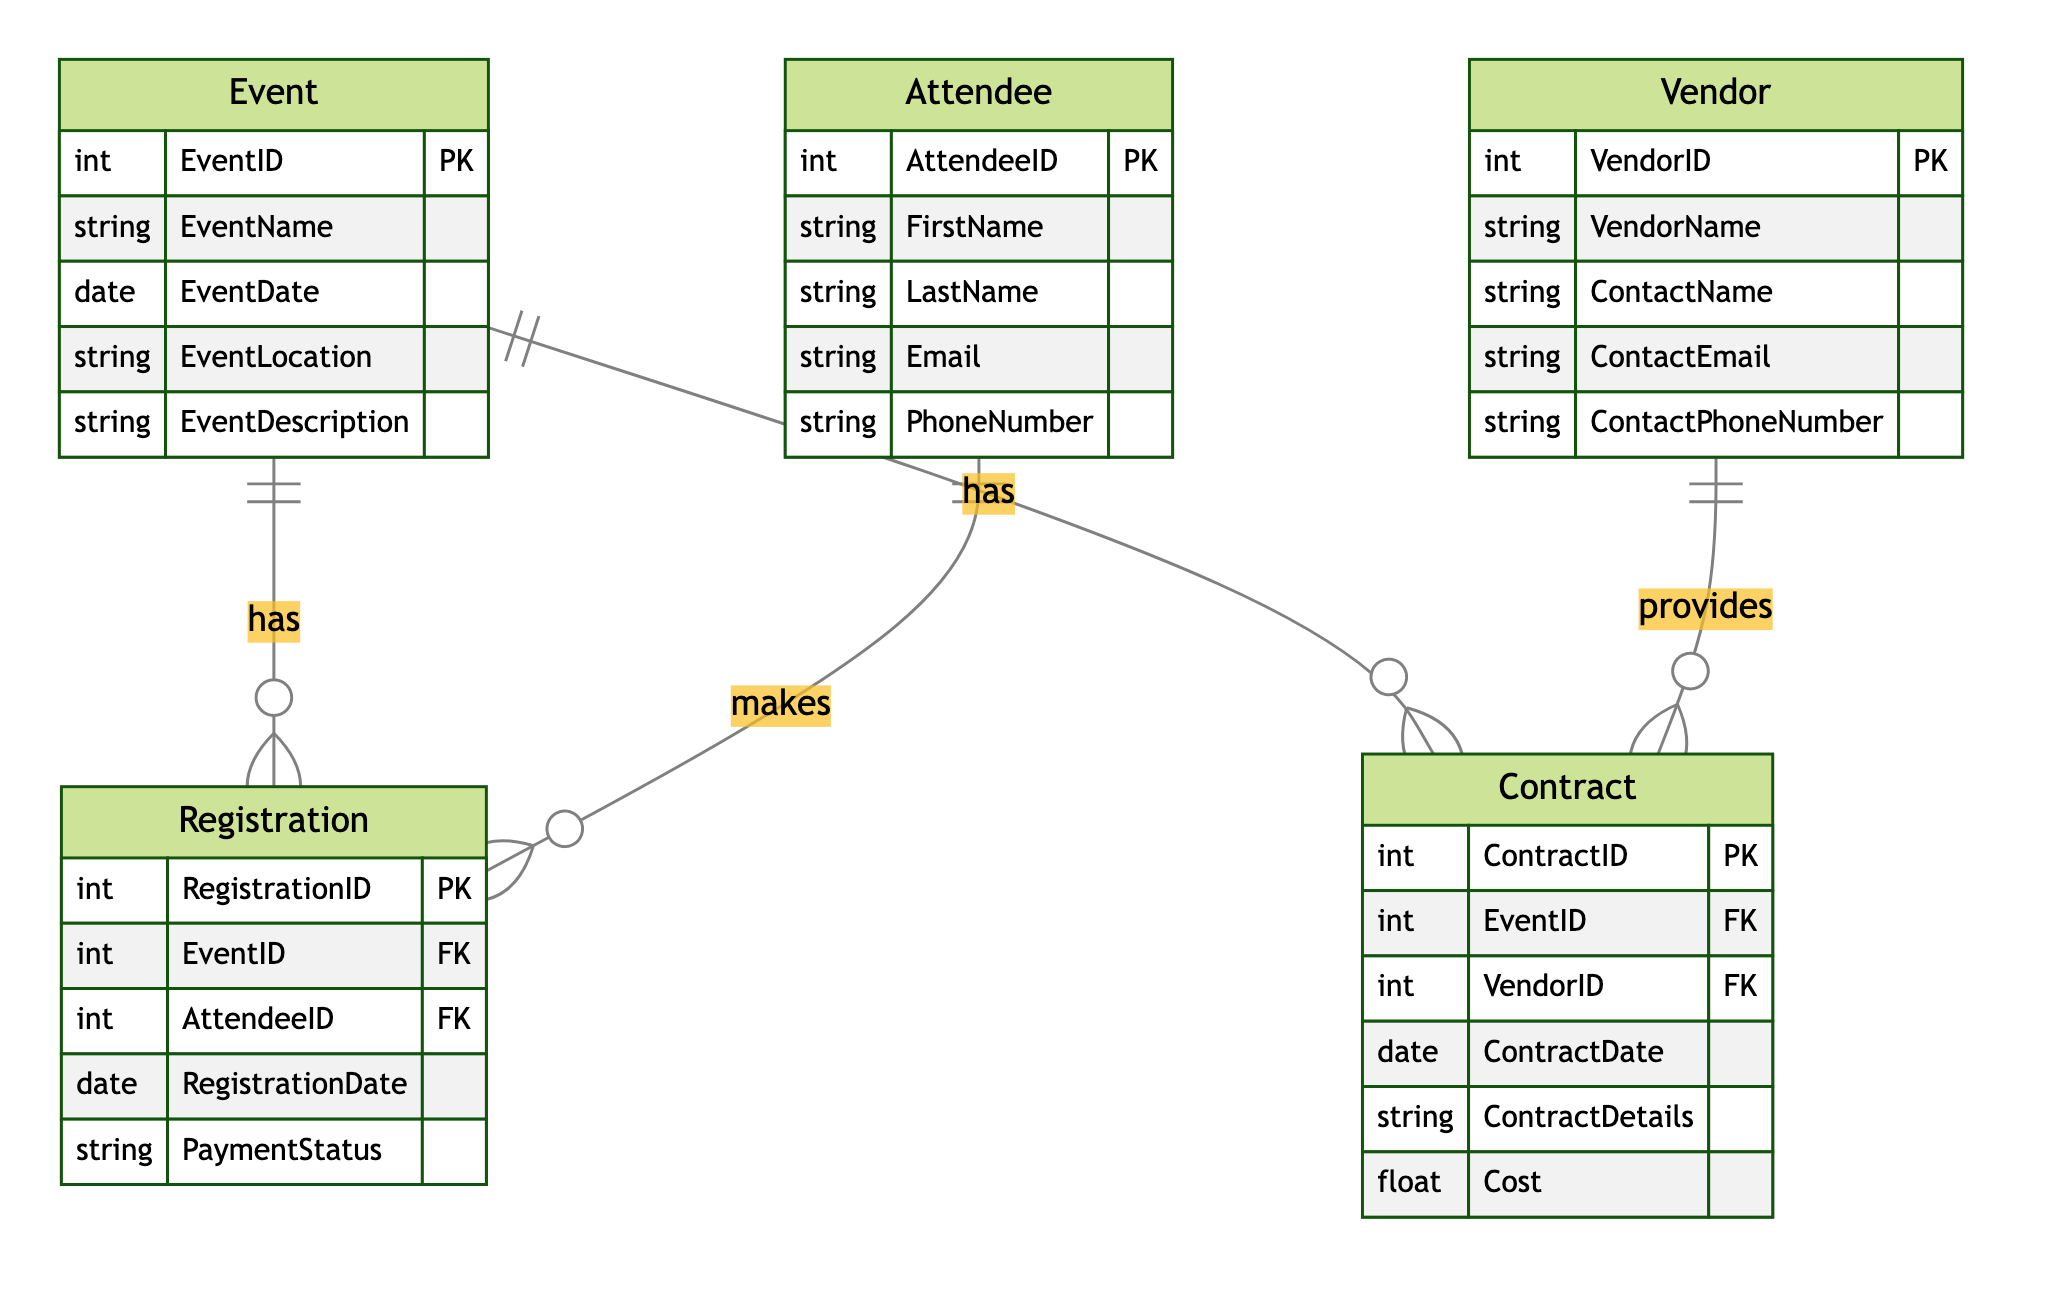What is the primary key of the Event entity? The primary key is defined in the diagram as the unique identifier for the Event entity. It is labeled as EventID, which indicates that this attribute serves as the primary key.
Answer: EventID How many relationships are there in the diagram? By reviewing the relationships section of the diagram, we can count the connections between different entities. There are four specified relationships in total: Event to Registration, Attendee to Registration, Event to Contract, and Vendor to Contract.
Answer: 4 What is the relationship between Event and Registration? The diagram showcases that the relationship is one-to-many, meaning that a single Event can have multiple Registrations associated with it. This is indicated by the notation on the connection line between the two entities.
Answer: one-to-many Which entity can have multiple contracts? The diagram illustrates that the Vendor entity has a one-to-many relationship with the Contract entity, indicating that a single Vendor can provide multiple Contracts for different Events. This is derived from the relationship line connecting Vendor to Contract.
Answer: Vendor What foreign keys are present in the Registration entity? By examining the attributes listed under the Registration entity in the diagram, we can identify the foreign keys. They are listed as EventID and AttendeeID, indicating these attributes reference the primary keys of the Event and Attendee entities, respectively.
Answer: EventID, AttendeeID What attributes does the Contract entity have? The attributes of the Contract entity are explicitly mentioned in the diagram. They include ContractID, ContractDate, ContractDetails, and Cost, describing the information stored within this entity.
Answer: ContractID, ContractDate, ContractDetails, Cost How many unique primary keys are there across all entities? In the diagram, each entity has one primary key, and there are five distinct entities listed: Event, Attendee, Registration, Vendor, and Contract. Thus, the total number of unique primary keys is five.
Answer: 5 What type of relationship exists between Attendee and Registration? The diagram classifies this relationship as one-to-many, indicating that one Attendee can make multiple Registrations for different Events. This is observed from the connecting relationship line indicating the multiplicity.
Answer: one-to-many 